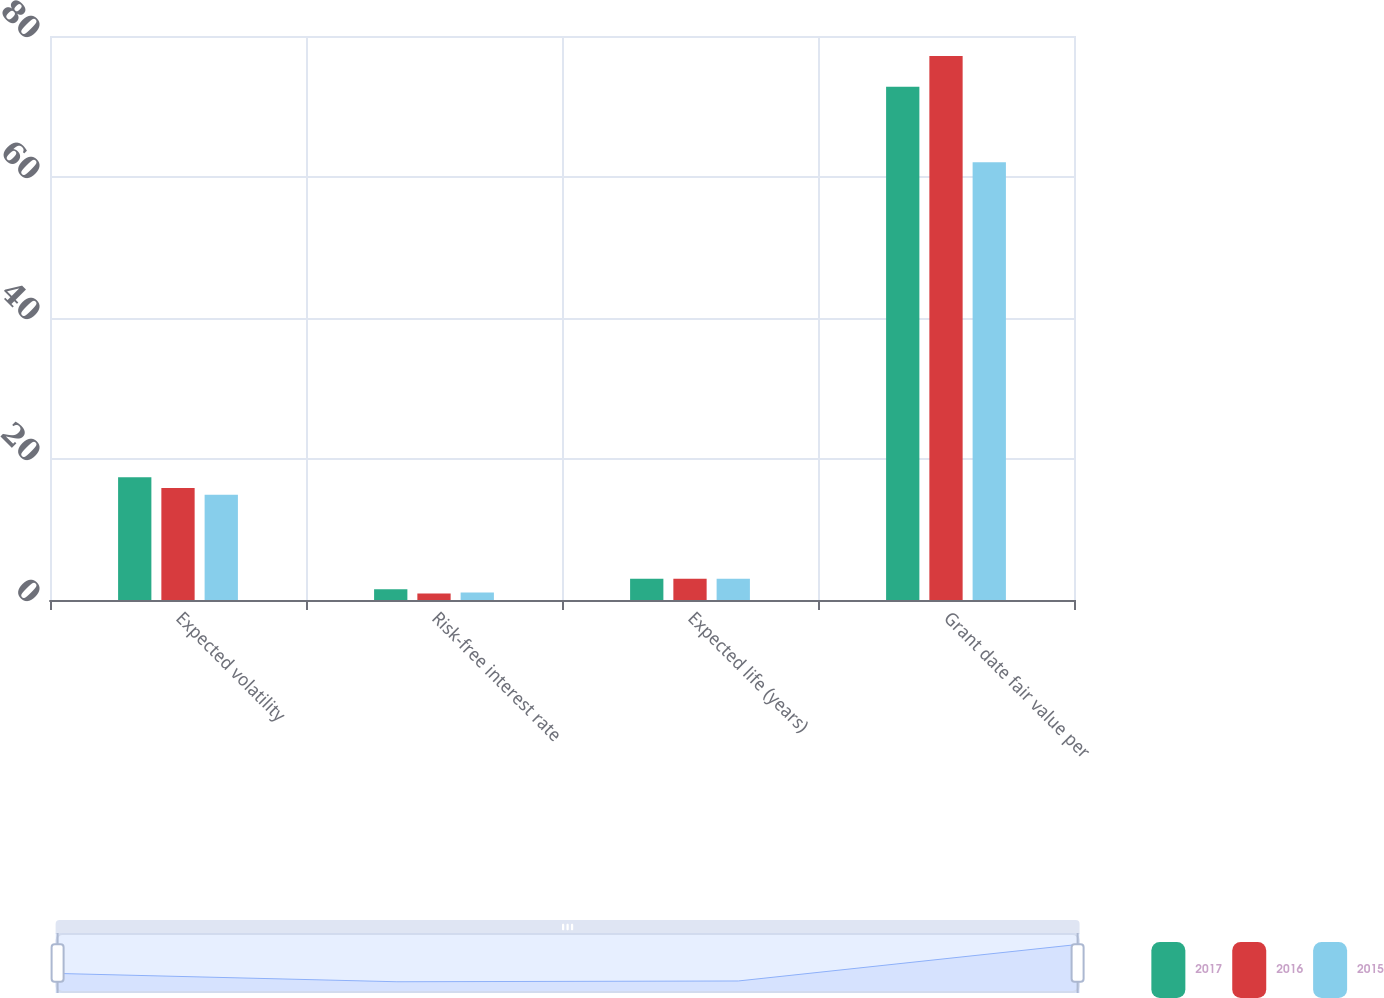<chart> <loc_0><loc_0><loc_500><loc_500><stacked_bar_chart><ecel><fcel>Expected volatility<fcel>Risk-free interest rate<fcel>Expected life (years)<fcel>Grant date fair value per<nl><fcel>2017<fcel>17.4<fcel>1.53<fcel>3<fcel>72.81<nl><fcel>2016<fcel>15.9<fcel>0.91<fcel>3<fcel>77.16<nl><fcel>2015<fcel>14.93<fcel>1.07<fcel>3<fcel>62.1<nl></chart> 